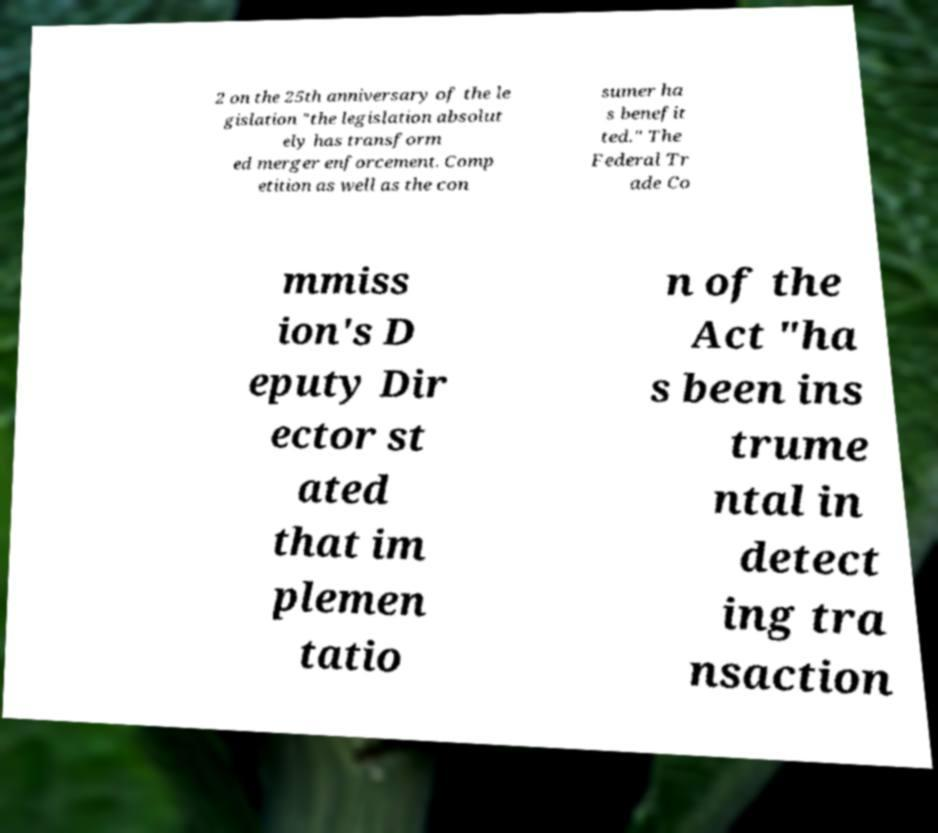For documentation purposes, I need the text within this image transcribed. Could you provide that? 2 on the 25th anniversary of the le gislation "the legislation absolut ely has transform ed merger enforcement. Comp etition as well as the con sumer ha s benefit ted." The Federal Tr ade Co mmiss ion's D eputy Dir ector st ated that im plemen tatio n of the Act "ha s been ins trume ntal in detect ing tra nsaction 